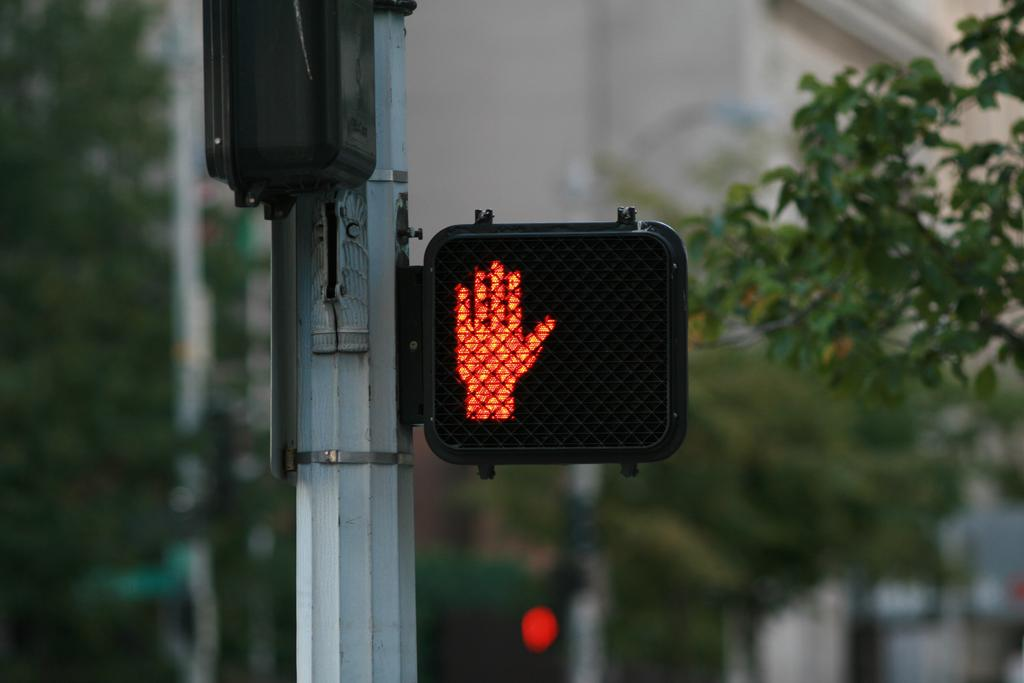What is located in the middle of the image? There is a traffic signal and a pole in the middle of the image. What can be seen on the right side of the image? There are trees on the right side of the image. What is visible in the background of the image? There is a building, trees, and a pole in the background of the image. What type of polish is being applied to the quartz in the image? There is no polish or quartz present in the image; it features a traffic signal, a pole, trees, and a building. How many hills are visible in the image? There are no hills visible in the image. 